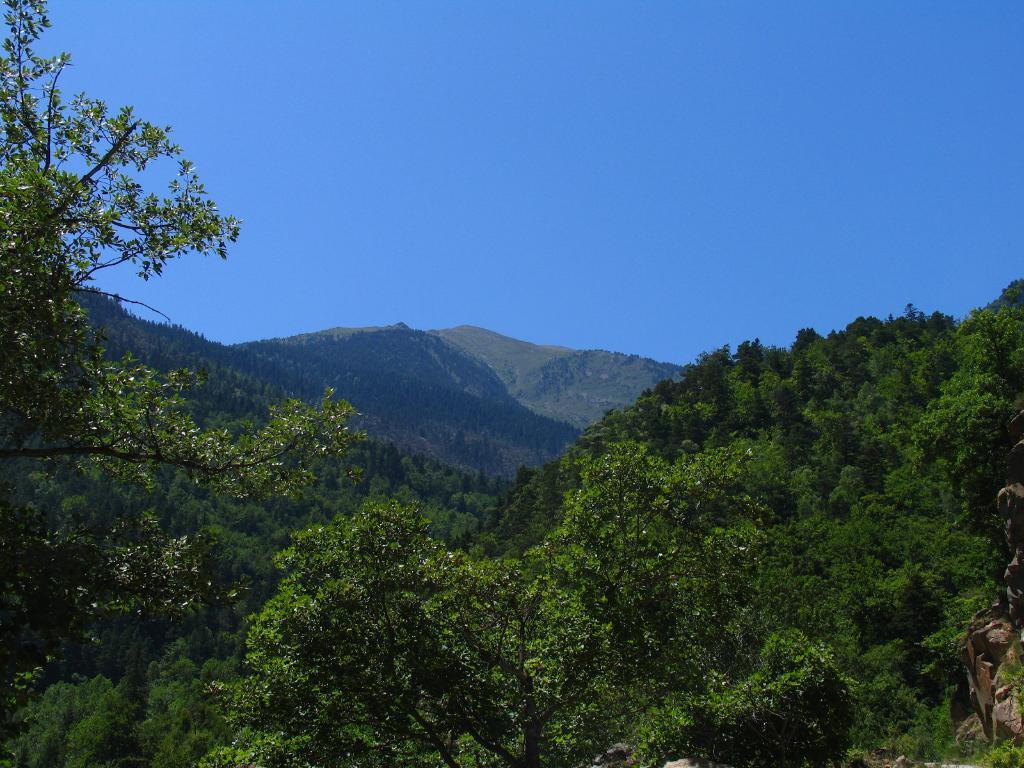How would you summarize this image in a sentence or two? In the picture we can see a forest area with full of trees and behind it, we can see a hill which is covered with trees and behind it we can see another hill and sky which is blue in color. 